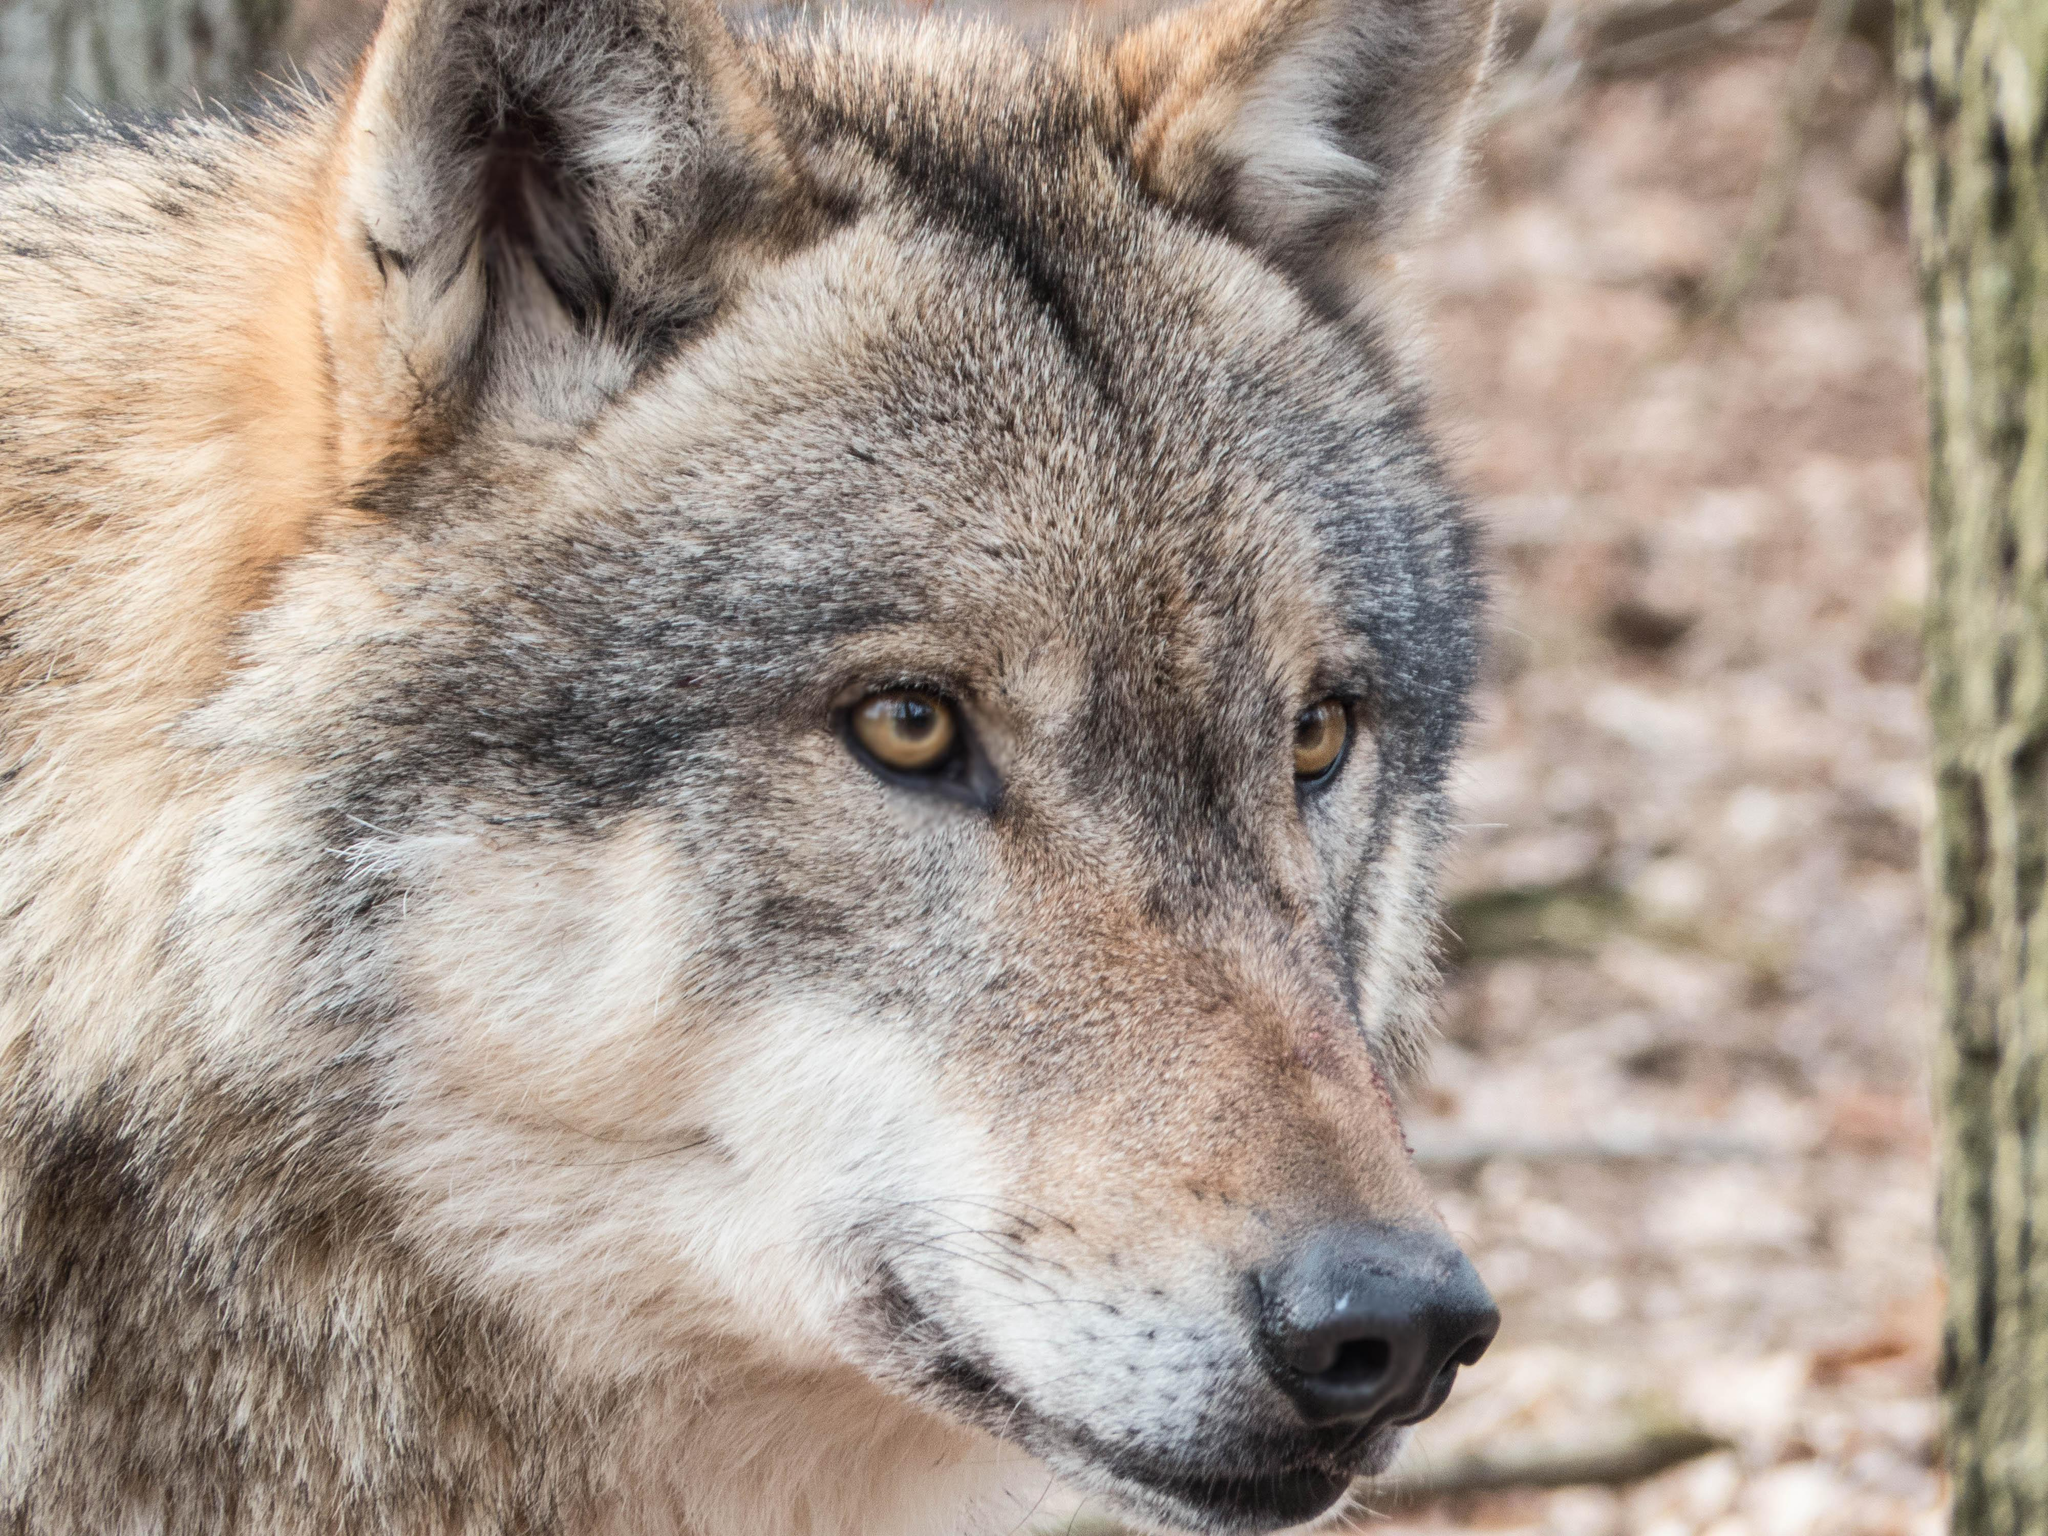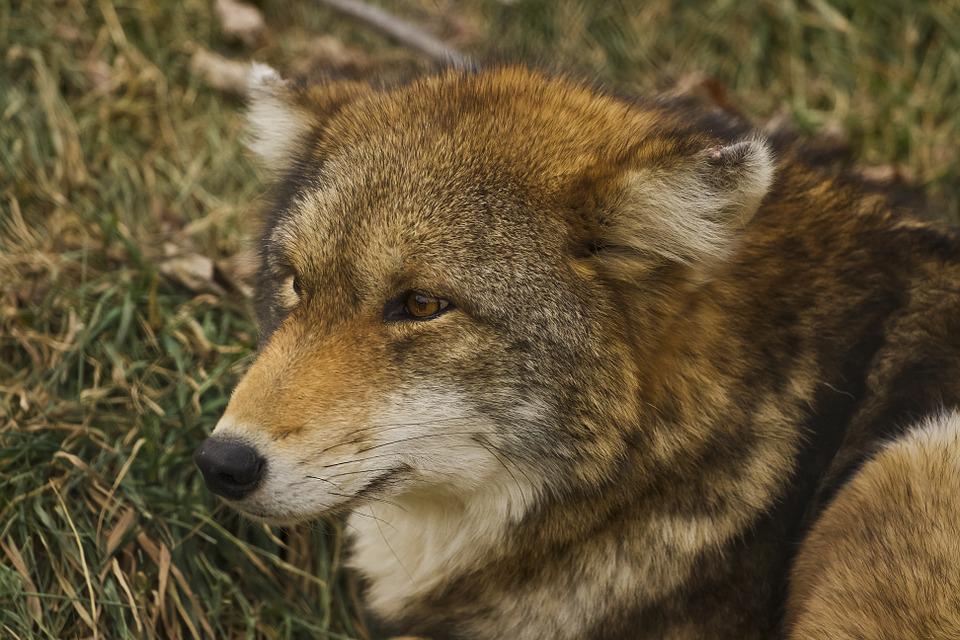The first image is the image on the left, the second image is the image on the right. Evaluate the accuracy of this statement regarding the images: "One image includes exactly twice as many wolves as the other image.". Is it true? Answer yes or no. No. The first image is the image on the left, the second image is the image on the right. Examine the images to the left and right. Is the description "There are three wolves" accurate? Answer yes or no. No. 